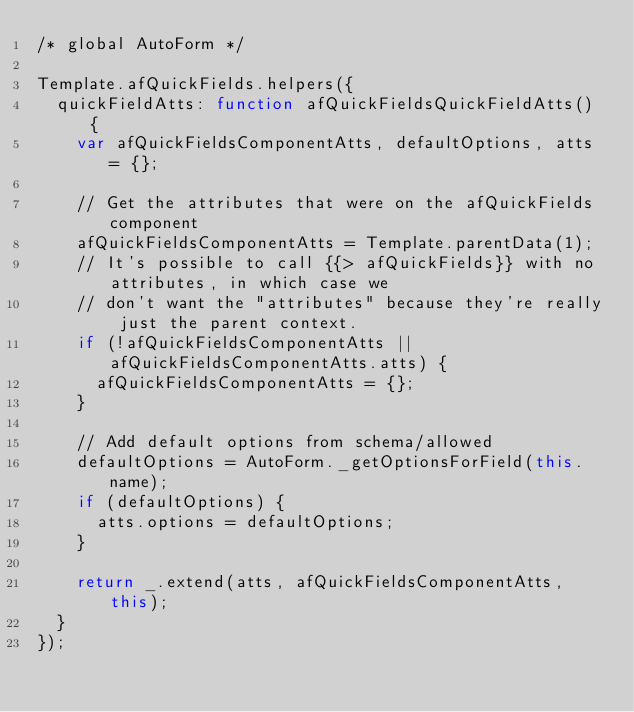<code> <loc_0><loc_0><loc_500><loc_500><_JavaScript_>/* global AutoForm */

Template.afQuickFields.helpers({
  quickFieldAtts: function afQuickFieldsQuickFieldAtts() {
    var afQuickFieldsComponentAtts, defaultOptions, atts = {};

    // Get the attributes that were on the afQuickFields component
    afQuickFieldsComponentAtts = Template.parentData(1);
    // It's possible to call {{> afQuickFields}} with no attributes, in which case we
    // don't want the "attributes" because they're really just the parent context.
    if (!afQuickFieldsComponentAtts || afQuickFieldsComponentAtts.atts) {
      afQuickFieldsComponentAtts = {};
    }

    // Add default options from schema/allowed
    defaultOptions = AutoForm._getOptionsForField(this.name);
    if (defaultOptions) {
      atts.options = defaultOptions;
    }

    return _.extend(atts, afQuickFieldsComponentAtts, this);
  }
});
</code> 